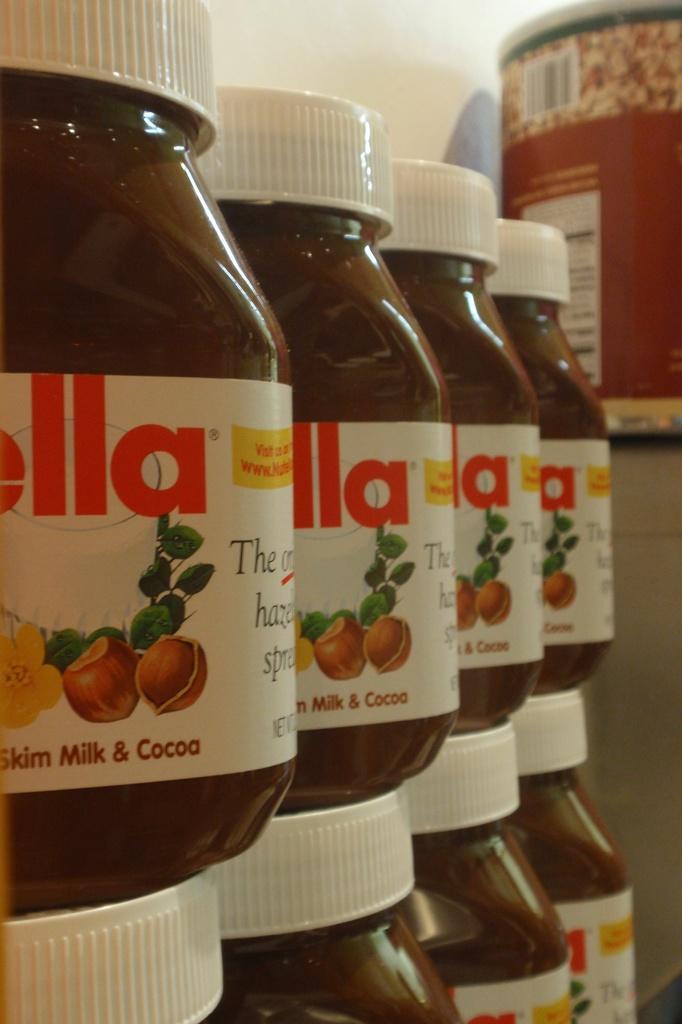Can you describe this image briefly? in this image i can see bottles of nutella. 